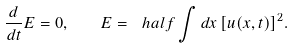<formula> <loc_0><loc_0><loc_500><loc_500>\frac { d } { d t } E = 0 , \quad E = \ h a l f \int d x \, [ u ( x , t ) ] ^ { 2 } .</formula> 